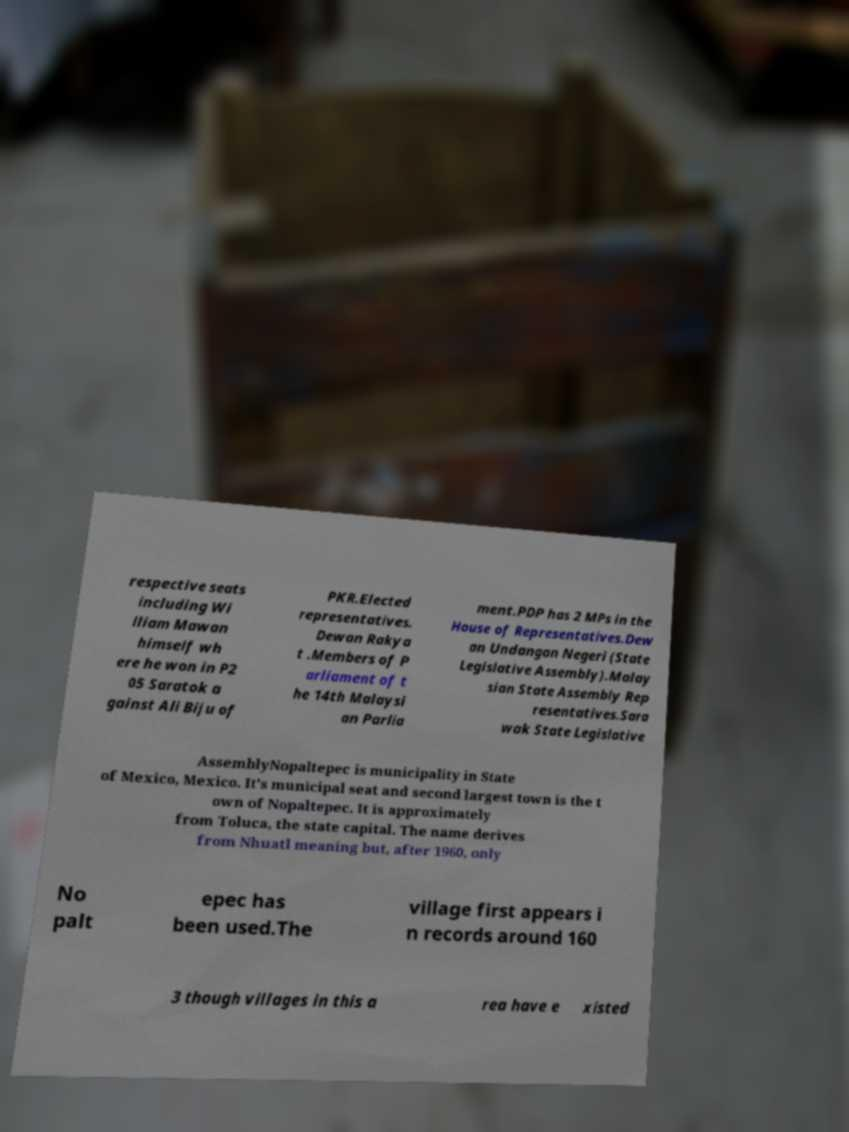Please identify and transcribe the text found in this image. respective seats including Wi lliam Mawan himself wh ere he won in P2 05 Saratok a gainst Ali Biju of PKR.Elected representatives. Dewan Rakya t .Members of P arliament of t he 14th Malaysi an Parlia ment.PDP has 2 MPs in the House of Representatives.Dew an Undangan Negeri (State Legislative Assembly).Malay sian State Assembly Rep resentatives.Sara wak State Legislative AssemblyNopaltepec is municipality in State of Mexico, Mexico. It's municipal seat and second largest town is the t own of Nopaltepec. It is approximately from Toluca, the state capital. The name derives from Nhuatl meaning but, after 1960, only No palt epec has been used.The village first appears i n records around 160 3 though villages in this a rea have e xisted 